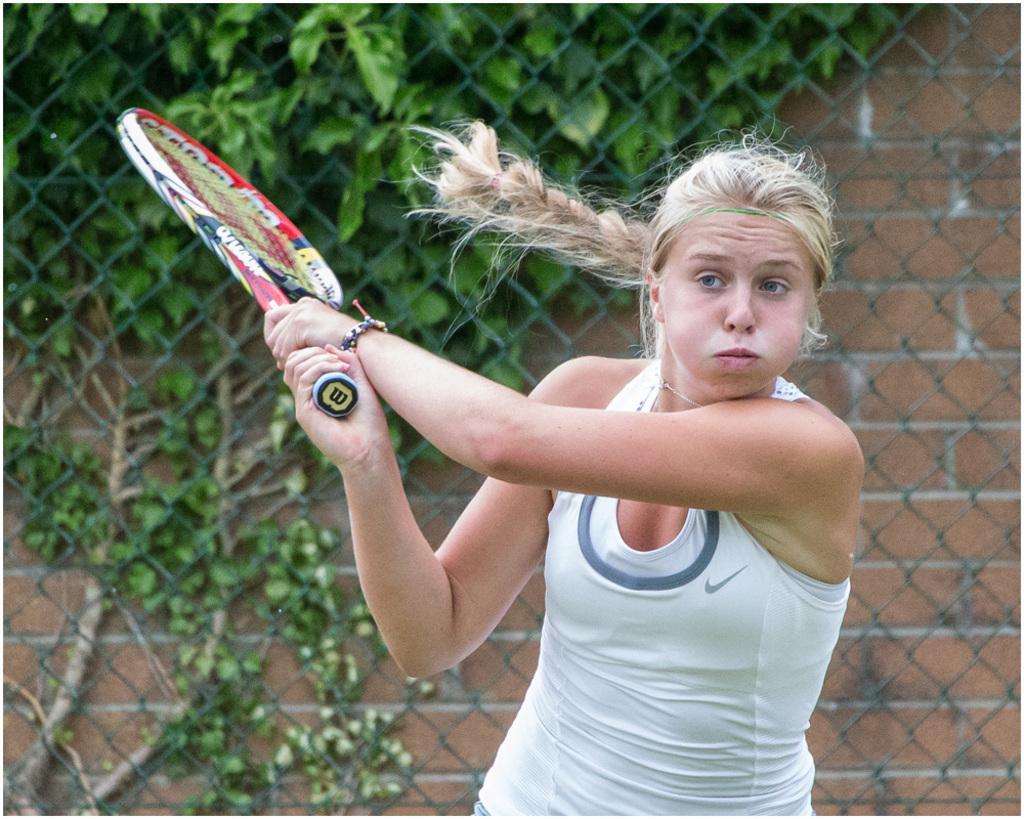In one or two sentences, can you explain what this image depicts? There is a woman holding a tennis racket. In the back there is a mesh fencing and a brick wall with a creeper on that. 